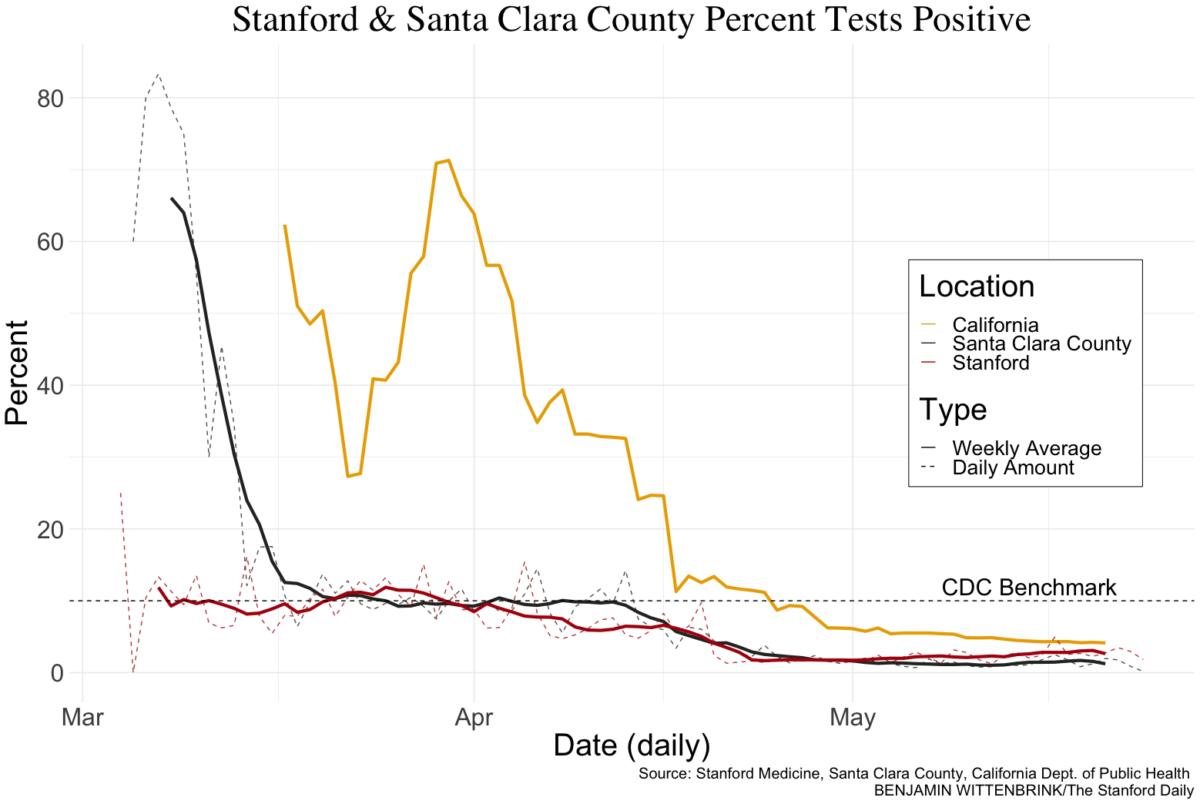Draw attention to some important aspects in this diagram. Stanford-yellow is represented by the color red. The daily amount can be represented using either bold or dotted lines. 